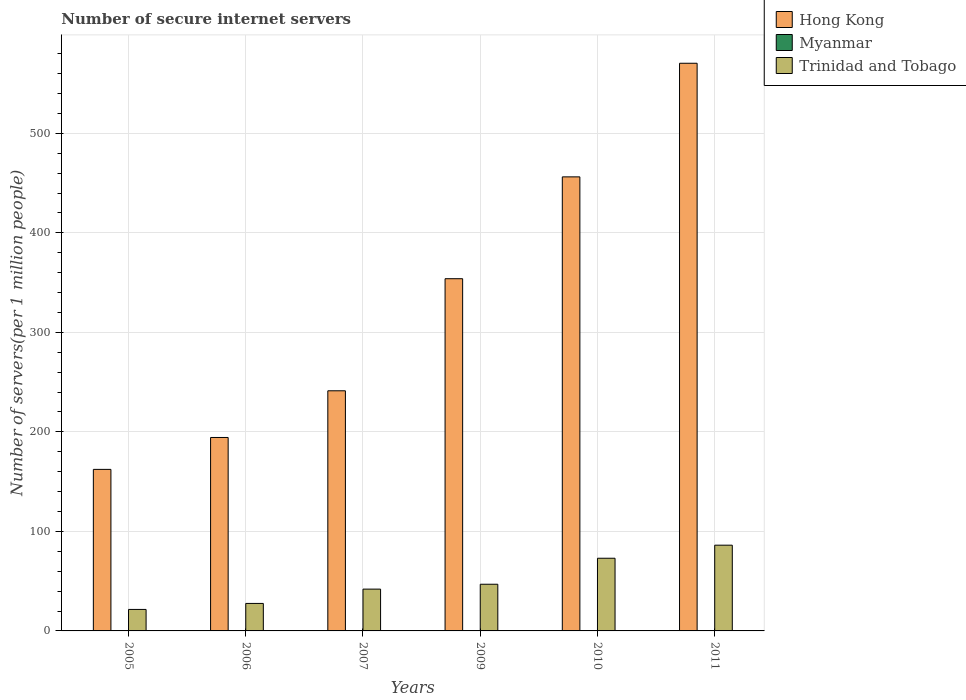Are the number of bars per tick equal to the number of legend labels?
Keep it short and to the point. Yes. What is the label of the 1st group of bars from the left?
Ensure brevity in your answer.  2005. What is the number of secure internet servers in Trinidad and Tobago in 2010?
Ensure brevity in your answer.  73.04. Across all years, what is the maximum number of secure internet servers in Trinidad and Tobago?
Keep it short and to the point. 86.16. Across all years, what is the minimum number of secure internet servers in Myanmar?
Give a very brief answer. 0.02. In which year was the number of secure internet servers in Hong Kong minimum?
Make the answer very short. 2005. What is the total number of secure internet servers in Hong Kong in the graph?
Ensure brevity in your answer.  1978.72. What is the difference between the number of secure internet servers in Hong Kong in 2006 and that in 2009?
Make the answer very short. -159.55. What is the difference between the number of secure internet servers in Trinidad and Tobago in 2011 and the number of secure internet servers in Myanmar in 2010?
Provide a succinct answer. 86.1. What is the average number of secure internet servers in Myanmar per year?
Your response must be concise. 0.04. In the year 2010, what is the difference between the number of secure internet servers in Trinidad and Tobago and number of secure internet servers in Myanmar?
Keep it short and to the point. 72.98. In how many years, is the number of secure internet servers in Myanmar greater than 280?
Ensure brevity in your answer.  0. What is the ratio of the number of secure internet servers in Hong Kong in 2006 to that in 2007?
Make the answer very short. 0.81. What is the difference between the highest and the second highest number of secure internet servers in Hong Kong?
Offer a very short reply. 114.17. What is the difference between the highest and the lowest number of secure internet servers in Trinidad and Tobago?
Offer a very short reply. 64.57. What does the 1st bar from the left in 2006 represents?
Ensure brevity in your answer.  Hong Kong. What does the 2nd bar from the right in 2010 represents?
Keep it short and to the point. Myanmar. Is it the case that in every year, the sum of the number of secure internet servers in Hong Kong and number of secure internet servers in Myanmar is greater than the number of secure internet servers in Trinidad and Tobago?
Make the answer very short. Yes. How many bars are there?
Provide a succinct answer. 18. How many years are there in the graph?
Provide a succinct answer. 6. What is the difference between two consecutive major ticks on the Y-axis?
Give a very brief answer. 100. Are the values on the major ticks of Y-axis written in scientific E-notation?
Give a very brief answer. No. Does the graph contain any zero values?
Offer a terse response. No. What is the title of the graph?
Your answer should be compact. Number of secure internet servers. Does "Haiti" appear as one of the legend labels in the graph?
Your response must be concise. No. What is the label or title of the Y-axis?
Make the answer very short. Number of servers(per 1 million people). What is the Number of servers(per 1 million people) of Hong Kong in 2005?
Offer a terse response. 162.33. What is the Number of servers(per 1 million people) in Myanmar in 2005?
Make the answer very short. 0.02. What is the Number of servers(per 1 million people) of Trinidad and Tobago in 2005?
Ensure brevity in your answer.  21.59. What is the Number of servers(per 1 million people) in Hong Kong in 2006?
Offer a terse response. 194.4. What is the Number of servers(per 1 million people) in Myanmar in 2006?
Your response must be concise. 0.04. What is the Number of servers(per 1 million people) of Trinidad and Tobago in 2006?
Provide a succinct answer. 27.63. What is the Number of servers(per 1 million people) in Hong Kong in 2007?
Provide a short and direct response. 241.31. What is the Number of servers(per 1 million people) of Myanmar in 2007?
Make the answer very short. 0.02. What is the Number of servers(per 1 million people) in Trinidad and Tobago in 2007?
Your answer should be very brief. 42.01. What is the Number of servers(per 1 million people) of Hong Kong in 2009?
Your response must be concise. 353.95. What is the Number of servers(per 1 million people) in Myanmar in 2009?
Provide a succinct answer. 0.02. What is the Number of servers(per 1 million people) in Trinidad and Tobago in 2009?
Offer a terse response. 46.91. What is the Number of servers(per 1 million people) in Hong Kong in 2010?
Make the answer very short. 456.28. What is the Number of servers(per 1 million people) of Myanmar in 2010?
Give a very brief answer. 0.06. What is the Number of servers(per 1 million people) in Trinidad and Tobago in 2010?
Your response must be concise. 73.04. What is the Number of servers(per 1 million people) of Hong Kong in 2011?
Make the answer very short. 570.45. What is the Number of servers(per 1 million people) of Myanmar in 2011?
Offer a terse response. 0.08. What is the Number of servers(per 1 million people) of Trinidad and Tobago in 2011?
Your answer should be compact. 86.16. Across all years, what is the maximum Number of servers(per 1 million people) of Hong Kong?
Keep it short and to the point. 570.45. Across all years, what is the maximum Number of servers(per 1 million people) of Myanmar?
Provide a short and direct response. 0.08. Across all years, what is the maximum Number of servers(per 1 million people) of Trinidad and Tobago?
Provide a short and direct response. 86.16. Across all years, what is the minimum Number of servers(per 1 million people) in Hong Kong?
Make the answer very short. 162.33. Across all years, what is the minimum Number of servers(per 1 million people) of Myanmar?
Provide a short and direct response. 0.02. Across all years, what is the minimum Number of servers(per 1 million people) in Trinidad and Tobago?
Offer a terse response. 21.59. What is the total Number of servers(per 1 million people) in Hong Kong in the graph?
Make the answer very short. 1978.72. What is the total Number of servers(per 1 million people) of Myanmar in the graph?
Your answer should be compact. 0.23. What is the total Number of servers(per 1 million people) of Trinidad and Tobago in the graph?
Your answer should be very brief. 297.33. What is the difference between the Number of servers(per 1 million people) of Hong Kong in 2005 and that in 2006?
Keep it short and to the point. -32.07. What is the difference between the Number of servers(per 1 million people) of Myanmar in 2005 and that in 2006?
Give a very brief answer. -0.02. What is the difference between the Number of servers(per 1 million people) in Trinidad and Tobago in 2005 and that in 2006?
Your response must be concise. -6.04. What is the difference between the Number of servers(per 1 million people) of Hong Kong in 2005 and that in 2007?
Provide a short and direct response. -78.98. What is the difference between the Number of servers(per 1 million people) in Myanmar in 2005 and that in 2007?
Your response must be concise. 0. What is the difference between the Number of servers(per 1 million people) in Trinidad and Tobago in 2005 and that in 2007?
Offer a terse response. -20.42. What is the difference between the Number of servers(per 1 million people) in Hong Kong in 2005 and that in 2009?
Your response must be concise. -191.61. What is the difference between the Number of servers(per 1 million people) of Myanmar in 2005 and that in 2009?
Offer a very short reply. 0. What is the difference between the Number of servers(per 1 million people) in Trinidad and Tobago in 2005 and that in 2009?
Your answer should be compact. -25.32. What is the difference between the Number of servers(per 1 million people) in Hong Kong in 2005 and that in 2010?
Ensure brevity in your answer.  -293.95. What is the difference between the Number of servers(per 1 million people) in Myanmar in 2005 and that in 2010?
Your answer should be very brief. -0.04. What is the difference between the Number of servers(per 1 million people) of Trinidad and Tobago in 2005 and that in 2010?
Make the answer very short. -51.45. What is the difference between the Number of servers(per 1 million people) in Hong Kong in 2005 and that in 2011?
Your response must be concise. -408.12. What is the difference between the Number of servers(per 1 million people) of Myanmar in 2005 and that in 2011?
Make the answer very short. -0.06. What is the difference between the Number of servers(per 1 million people) in Trinidad and Tobago in 2005 and that in 2011?
Provide a succinct answer. -64.57. What is the difference between the Number of servers(per 1 million people) of Hong Kong in 2006 and that in 2007?
Ensure brevity in your answer.  -46.92. What is the difference between the Number of servers(per 1 million people) of Myanmar in 2006 and that in 2007?
Make the answer very short. 0.02. What is the difference between the Number of servers(per 1 million people) of Trinidad and Tobago in 2006 and that in 2007?
Ensure brevity in your answer.  -14.38. What is the difference between the Number of servers(per 1 million people) of Hong Kong in 2006 and that in 2009?
Keep it short and to the point. -159.55. What is the difference between the Number of servers(per 1 million people) of Myanmar in 2006 and that in 2009?
Keep it short and to the point. 0.02. What is the difference between the Number of servers(per 1 million people) in Trinidad and Tobago in 2006 and that in 2009?
Give a very brief answer. -19.29. What is the difference between the Number of servers(per 1 million people) of Hong Kong in 2006 and that in 2010?
Provide a succinct answer. -261.88. What is the difference between the Number of servers(per 1 million people) of Myanmar in 2006 and that in 2010?
Ensure brevity in your answer.  -0.02. What is the difference between the Number of servers(per 1 million people) of Trinidad and Tobago in 2006 and that in 2010?
Offer a terse response. -45.41. What is the difference between the Number of servers(per 1 million people) in Hong Kong in 2006 and that in 2011?
Your answer should be compact. -376.05. What is the difference between the Number of servers(per 1 million people) of Myanmar in 2006 and that in 2011?
Offer a very short reply. -0.04. What is the difference between the Number of servers(per 1 million people) in Trinidad and Tobago in 2006 and that in 2011?
Ensure brevity in your answer.  -58.53. What is the difference between the Number of servers(per 1 million people) in Hong Kong in 2007 and that in 2009?
Your response must be concise. -112.63. What is the difference between the Number of servers(per 1 million people) in Trinidad and Tobago in 2007 and that in 2009?
Give a very brief answer. -4.9. What is the difference between the Number of servers(per 1 million people) of Hong Kong in 2007 and that in 2010?
Offer a terse response. -214.97. What is the difference between the Number of servers(per 1 million people) of Myanmar in 2007 and that in 2010?
Provide a succinct answer. -0.04. What is the difference between the Number of servers(per 1 million people) of Trinidad and Tobago in 2007 and that in 2010?
Your response must be concise. -31.03. What is the difference between the Number of servers(per 1 million people) in Hong Kong in 2007 and that in 2011?
Give a very brief answer. -329.14. What is the difference between the Number of servers(per 1 million people) of Myanmar in 2007 and that in 2011?
Offer a very short reply. -0.06. What is the difference between the Number of servers(per 1 million people) of Trinidad and Tobago in 2007 and that in 2011?
Provide a succinct answer. -44.15. What is the difference between the Number of servers(per 1 million people) of Hong Kong in 2009 and that in 2010?
Keep it short and to the point. -102.33. What is the difference between the Number of servers(per 1 million people) in Myanmar in 2009 and that in 2010?
Ensure brevity in your answer.  -0.04. What is the difference between the Number of servers(per 1 million people) in Trinidad and Tobago in 2009 and that in 2010?
Your answer should be very brief. -26.12. What is the difference between the Number of servers(per 1 million people) in Hong Kong in 2009 and that in 2011?
Your answer should be compact. -216.5. What is the difference between the Number of servers(per 1 million people) of Myanmar in 2009 and that in 2011?
Provide a succinct answer. -0.06. What is the difference between the Number of servers(per 1 million people) in Trinidad and Tobago in 2009 and that in 2011?
Make the answer very short. -39.24. What is the difference between the Number of servers(per 1 million people) in Hong Kong in 2010 and that in 2011?
Your answer should be very brief. -114.17. What is the difference between the Number of servers(per 1 million people) in Myanmar in 2010 and that in 2011?
Ensure brevity in your answer.  -0.02. What is the difference between the Number of servers(per 1 million people) in Trinidad and Tobago in 2010 and that in 2011?
Provide a succinct answer. -13.12. What is the difference between the Number of servers(per 1 million people) of Hong Kong in 2005 and the Number of servers(per 1 million people) of Myanmar in 2006?
Keep it short and to the point. 162.29. What is the difference between the Number of servers(per 1 million people) in Hong Kong in 2005 and the Number of servers(per 1 million people) in Trinidad and Tobago in 2006?
Offer a terse response. 134.71. What is the difference between the Number of servers(per 1 million people) in Myanmar in 2005 and the Number of servers(per 1 million people) in Trinidad and Tobago in 2006?
Keep it short and to the point. -27.61. What is the difference between the Number of servers(per 1 million people) of Hong Kong in 2005 and the Number of servers(per 1 million people) of Myanmar in 2007?
Keep it short and to the point. 162.31. What is the difference between the Number of servers(per 1 million people) of Hong Kong in 2005 and the Number of servers(per 1 million people) of Trinidad and Tobago in 2007?
Provide a succinct answer. 120.32. What is the difference between the Number of servers(per 1 million people) in Myanmar in 2005 and the Number of servers(per 1 million people) in Trinidad and Tobago in 2007?
Offer a very short reply. -41.99. What is the difference between the Number of servers(per 1 million people) in Hong Kong in 2005 and the Number of servers(per 1 million people) in Myanmar in 2009?
Keep it short and to the point. 162.31. What is the difference between the Number of servers(per 1 million people) in Hong Kong in 2005 and the Number of servers(per 1 million people) in Trinidad and Tobago in 2009?
Your answer should be very brief. 115.42. What is the difference between the Number of servers(per 1 million people) of Myanmar in 2005 and the Number of servers(per 1 million people) of Trinidad and Tobago in 2009?
Offer a terse response. -46.89. What is the difference between the Number of servers(per 1 million people) of Hong Kong in 2005 and the Number of servers(per 1 million people) of Myanmar in 2010?
Give a very brief answer. 162.27. What is the difference between the Number of servers(per 1 million people) in Hong Kong in 2005 and the Number of servers(per 1 million people) in Trinidad and Tobago in 2010?
Give a very brief answer. 89.3. What is the difference between the Number of servers(per 1 million people) of Myanmar in 2005 and the Number of servers(per 1 million people) of Trinidad and Tobago in 2010?
Provide a short and direct response. -73.02. What is the difference between the Number of servers(per 1 million people) of Hong Kong in 2005 and the Number of servers(per 1 million people) of Myanmar in 2011?
Your answer should be compact. 162.26. What is the difference between the Number of servers(per 1 million people) of Hong Kong in 2005 and the Number of servers(per 1 million people) of Trinidad and Tobago in 2011?
Provide a succinct answer. 76.18. What is the difference between the Number of servers(per 1 million people) of Myanmar in 2005 and the Number of servers(per 1 million people) of Trinidad and Tobago in 2011?
Provide a short and direct response. -86.14. What is the difference between the Number of servers(per 1 million people) in Hong Kong in 2006 and the Number of servers(per 1 million people) in Myanmar in 2007?
Keep it short and to the point. 194.38. What is the difference between the Number of servers(per 1 million people) in Hong Kong in 2006 and the Number of servers(per 1 million people) in Trinidad and Tobago in 2007?
Give a very brief answer. 152.39. What is the difference between the Number of servers(per 1 million people) in Myanmar in 2006 and the Number of servers(per 1 million people) in Trinidad and Tobago in 2007?
Your response must be concise. -41.97. What is the difference between the Number of servers(per 1 million people) in Hong Kong in 2006 and the Number of servers(per 1 million people) in Myanmar in 2009?
Ensure brevity in your answer.  194.38. What is the difference between the Number of servers(per 1 million people) of Hong Kong in 2006 and the Number of servers(per 1 million people) of Trinidad and Tobago in 2009?
Your response must be concise. 147.49. What is the difference between the Number of servers(per 1 million people) of Myanmar in 2006 and the Number of servers(per 1 million people) of Trinidad and Tobago in 2009?
Ensure brevity in your answer.  -46.87. What is the difference between the Number of servers(per 1 million people) in Hong Kong in 2006 and the Number of servers(per 1 million people) in Myanmar in 2010?
Keep it short and to the point. 194.34. What is the difference between the Number of servers(per 1 million people) of Hong Kong in 2006 and the Number of servers(per 1 million people) of Trinidad and Tobago in 2010?
Ensure brevity in your answer.  121.36. What is the difference between the Number of servers(per 1 million people) in Myanmar in 2006 and the Number of servers(per 1 million people) in Trinidad and Tobago in 2010?
Your answer should be very brief. -73. What is the difference between the Number of servers(per 1 million people) of Hong Kong in 2006 and the Number of servers(per 1 million people) of Myanmar in 2011?
Give a very brief answer. 194.32. What is the difference between the Number of servers(per 1 million people) of Hong Kong in 2006 and the Number of servers(per 1 million people) of Trinidad and Tobago in 2011?
Ensure brevity in your answer.  108.24. What is the difference between the Number of servers(per 1 million people) in Myanmar in 2006 and the Number of servers(per 1 million people) in Trinidad and Tobago in 2011?
Give a very brief answer. -86.12. What is the difference between the Number of servers(per 1 million people) of Hong Kong in 2007 and the Number of servers(per 1 million people) of Myanmar in 2009?
Provide a short and direct response. 241.29. What is the difference between the Number of servers(per 1 million people) in Hong Kong in 2007 and the Number of servers(per 1 million people) in Trinidad and Tobago in 2009?
Make the answer very short. 194.4. What is the difference between the Number of servers(per 1 million people) in Myanmar in 2007 and the Number of servers(per 1 million people) in Trinidad and Tobago in 2009?
Offer a very short reply. -46.89. What is the difference between the Number of servers(per 1 million people) in Hong Kong in 2007 and the Number of servers(per 1 million people) in Myanmar in 2010?
Your response must be concise. 241.26. What is the difference between the Number of servers(per 1 million people) in Hong Kong in 2007 and the Number of servers(per 1 million people) in Trinidad and Tobago in 2010?
Your response must be concise. 168.28. What is the difference between the Number of servers(per 1 million people) of Myanmar in 2007 and the Number of servers(per 1 million people) of Trinidad and Tobago in 2010?
Provide a succinct answer. -73.02. What is the difference between the Number of servers(per 1 million people) in Hong Kong in 2007 and the Number of servers(per 1 million people) in Myanmar in 2011?
Provide a short and direct response. 241.24. What is the difference between the Number of servers(per 1 million people) of Hong Kong in 2007 and the Number of servers(per 1 million people) of Trinidad and Tobago in 2011?
Provide a succinct answer. 155.16. What is the difference between the Number of servers(per 1 million people) of Myanmar in 2007 and the Number of servers(per 1 million people) of Trinidad and Tobago in 2011?
Offer a terse response. -86.14. What is the difference between the Number of servers(per 1 million people) of Hong Kong in 2009 and the Number of servers(per 1 million people) of Myanmar in 2010?
Give a very brief answer. 353.89. What is the difference between the Number of servers(per 1 million people) in Hong Kong in 2009 and the Number of servers(per 1 million people) in Trinidad and Tobago in 2010?
Your answer should be compact. 280.91. What is the difference between the Number of servers(per 1 million people) of Myanmar in 2009 and the Number of servers(per 1 million people) of Trinidad and Tobago in 2010?
Offer a terse response. -73.02. What is the difference between the Number of servers(per 1 million people) of Hong Kong in 2009 and the Number of servers(per 1 million people) of Myanmar in 2011?
Make the answer very short. 353.87. What is the difference between the Number of servers(per 1 million people) of Hong Kong in 2009 and the Number of servers(per 1 million people) of Trinidad and Tobago in 2011?
Provide a succinct answer. 267.79. What is the difference between the Number of servers(per 1 million people) of Myanmar in 2009 and the Number of servers(per 1 million people) of Trinidad and Tobago in 2011?
Ensure brevity in your answer.  -86.14. What is the difference between the Number of servers(per 1 million people) of Hong Kong in 2010 and the Number of servers(per 1 million people) of Myanmar in 2011?
Provide a succinct answer. 456.2. What is the difference between the Number of servers(per 1 million people) of Hong Kong in 2010 and the Number of servers(per 1 million people) of Trinidad and Tobago in 2011?
Ensure brevity in your answer.  370.12. What is the difference between the Number of servers(per 1 million people) of Myanmar in 2010 and the Number of servers(per 1 million people) of Trinidad and Tobago in 2011?
Your answer should be compact. -86.1. What is the average Number of servers(per 1 million people) of Hong Kong per year?
Ensure brevity in your answer.  329.79. What is the average Number of servers(per 1 million people) in Myanmar per year?
Your answer should be very brief. 0.04. What is the average Number of servers(per 1 million people) in Trinidad and Tobago per year?
Keep it short and to the point. 49.55. In the year 2005, what is the difference between the Number of servers(per 1 million people) of Hong Kong and Number of servers(per 1 million people) of Myanmar?
Offer a terse response. 162.31. In the year 2005, what is the difference between the Number of servers(per 1 million people) in Hong Kong and Number of servers(per 1 million people) in Trinidad and Tobago?
Provide a succinct answer. 140.74. In the year 2005, what is the difference between the Number of servers(per 1 million people) in Myanmar and Number of servers(per 1 million people) in Trinidad and Tobago?
Offer a very short reply. -21.57. In the year 2006, what is the difference between the Number of servers(per 1 million people) in Hong Kong and Number of servers(per 1 million people) in Myanmar?
Offer a very short reply. 194.36. In the year 2006, what is the difference between the Number of servers(per 1 million people) of Hong Kong and Number of servers(per 1 million people) of Trinidad and Tobago?
Offer a very short reply. 166.77. In the year 2006, what is the difference between the Number of servers(per 1 million people) in Myanmar and Number of servers(per 1 million people) in Trinidad and Tobago?
Give a very brief answer. -27.59. In the year 2007, what is the difference between the Number of servers(per 1 million people) in Hong Kong and Number of servers(per 1 million people) in Myanmar?
Your answer should be very brief. 241.29. In the year 2007, what is the difference between the Number of servers(per 1 million people) in Hong Kong and Number of servers(per 1 million people) in Trinidad and Tobago?
Offer a terse response. 199.31. In the year 2007, what is the difference between the Number of servers(per 1 million people) of Myanmar and Number of servers(per 1 million people) of Trinidad and Tobago?
Provide a short and direct response. -41.99. In the year 2009, what is the difference between the Number of servers(per 1 million people) in Hong Kong and Number of servers(per 1 million people) in Myanmar?
Keep it short and to the point. 353.93. In the year 2009, what is the difference between the Number of servers(per 1 million people) in Hong Kong and Number of servers(per 1 million people) in Trinidad and Tobago?
Your answer should be compact. 307.03. In the year 2009, what is the difference between the Number of servers(per 1 million people) in Myanmar and Number of servers(per 1 million people) in Trinidad and Tobago?
Your answer should be compact. -46.89. In the year 2010, what is the difference between the Number of servers(per 1 million people) of Hong Kong and Number of servers(per 1 million people) of Myanmar?
Ensure brevity in your answer.  456.22. In the year 2010, what is the difference between the Number of servers(per 1 million people) of Hong Kong and Number of servers(per 1 million people) of Trinidad and Tobago?
Your response must be concise. 383.24. In the year 2010, what is the difference between the Number of servers(per 1 million people) of Myanmar and Number of servers(per 1 million people) of Trinidad and Tobago?
Your answer should be very brief. -72.98. In the year 2011, what is the difference between the Number of servers(per 1 million people) in Hong Kong and Number of servers(per 1 million people) in Myanmar?
Make the answer very short. 570.37. In the year 2011, what is the difference between the Number of servers(per 1 million people) in Hong Kong and Number of servers(per 1 million people) in Trinidad and Tobago?
Your answer should be compact. 484.29. In the year 2011, what is the difference between the Number of servers(per 1 million people) of Myanmar and Number of servers(per 1 million people) of Trinidad and Tobago?
Offer a very short reply. -86.08. What is the ratio of the Number of servers(per 1 million people) of Hong Kong in 2005 to that in 2006?
Your answer should be compact. 0.84. What is the ratio of the Number of servers(per 1 million people) of Myanmar in 2005 to that in 2006?
Offer a terse response. 0.5. What is the ratio of the Number of servers(per 1 million people) in Trinidad and Tobago in 2005 to that in 2006?
Your answer should be compact. 0.78. What is the ratio of the Number of servers(per 1 million people) of Hong Kong in 2005 to that in 2007?
Your answer should be very brief. 0.67. What is the ratio of the Number of servers(per 1 million people) of Myanmar in 2005 to that in 2007?
Your response must be concise. 1.01. What is the ratio of the Number of servers(per 1 million people) in Trinidad and Tobago in 2005 to that in 2007?
Keep it short and to the point. 0.51. What is the ratio of the Number of servers(per 1 million people) of Hong Kong in 2005 to that in 2009?
Your answer should be very brief. 0.46. What is the ratio of the Number of servers(per 1 million people) in Myanmar in 2005 to that in 2009?
Your response must be concise. 1.03. What is the ratio of the Number of servers(per 1 million people) in Trinidad and Tobago in 2005 to that in 2009?
Keep it short and to the point. 0.46. What is the ratio of the Number of servers(per 1 million people) in Hong Kong in 2005 to that in 2010?
Offer a very short reply. 0.36. What is the ratio of the Number of servers(per 1 million people) of Myanmar in 2005 to that in 2010?
Your answer should be compact. 0.34. What is the ratio of the Number of servers(per 1 million people) of Trinidad and Tobago in 2005 to that in 2010?
Provide a succinct answer. 0.3. What is the ratio of the Number of servers(per 1 million people) of Hong Kong in 2005 to that in 2011?
Your answer should be very brief. 0.28. What is the ratio of the Number of servers(per 1 million people) of Myanmar in 2005 to that in 2011?
Provide a succinct answer. 0.26. What is the ratio of the Number of servers(per 1 million people) in Trinidad and Tobago in 2005 to that in 2011?
Your answer should be very brief. 0.25. What is the ratio of the Number of servers(per 1 million people) of Hong Kong in 2006 to that in 2007?
Offer a terse response. 0.81. What is the ratio of the Number of servers(per 1 million people) of Myanmar in 2006 to that in 2007?
Ensure brevity in your answer.  2.01. What is the ratio of the Number of servers(per 1 million people) of Trinidad and Tobago in 2006 to that in 2007?
Give a very brief answer. 0.66. What is the ratio of the Number of servers(per 1 million people) of Hong Kong in 2006 to that in 2009?
Your answer should be very brief. 0.55. What is the ratio of the Number of servers(per 1 million people) in Myanmar in 2006 to that in 2009?
Ensure brevity in your answer.  2.04. What is the ratio of the Number of servers(per 1 million people) in Trinidad and Tobago in 2006 to that in 2009?
Offer a very short reply. 0.59. What is the ratio of the Number of servers(per 1 million people) in Hong Kong in 2006 to that in 2010?
Offer a terse response. 0.43. What is the ratio of the Number of servers(per 1 million people) of Myanmar in 2006 to that in 2010?
Provide a short and direct response. 0.68. What is the ratio of the Number of servers(per 1 million people) in Trinidad and Tobago in 2006 to that in 2010?
Keep it short and to the point. 0.38. What is the ratio of the Number of servers(per 1 million people) of Hong Kong in 2006 to that in 2011?
Make the answer very short. 0.34. What is the ratio of the Number of servers(per 1 million people) of Myanmar in 2006 to that in 2011?
Make the answer very short. 0.52. What is the ratio of the Number of servers(per 1 million people) in Trinidad and Tobago in 2006 to that in 2011?
Keep it short and to the point. 0.32. What is the ratio of the Number of servers(per 1 million people) in Hong Kong in 2007 to that in 2009?
Your answer should be very brief. 0.68. What is the ratio of the Number of servers(per 1 million people) of Myanmar in 2007 to that in 2009?
Keep it short and to the point. 1.01. What is the ratio of the Number of servers(per 1 million people) of Trinidad and Tobago in 2007 to that in 2009?
Give a very brief answer. 0.9. What is the ratio of the Number of servers(per 1 million people) of Hong Kong in 2007 to that in 2010?
Make the answer very short. 0.53. What is the ratio of the Number of servers(per 1 million people) in Myanmar in 2007 to that in 2010?
Your answer should be very brief. 0.34. What is the ratio of the Number of servers(per 1 million people) in Trinidad and Tobago in 2007 to that in 2010?
Provide a succinct answer. 0.58. What is the ratio of the Number of servers(per 1 million people) of Hong Kong in 2007 to that in 2011?
Keep it short and to the point. 0.42. What is the ratio of the Number of servers(per 1 million people) in Myanmar in 2007 to that in 2011?
Your response must be concise. 0.26. What is the ratio of the Number of servers(per 1 million people) in Trinidad and Tobago in 2007 to that in 2011?
Provide a succinct answer. 0.49. What is the ratio of the Number of servers(per 1 million people) in Hong Kong in 2009 to that in 2010?
Your answer should be compact. 0.78. What is the ratio of the Number of servers(per 1 million people) in Myanmar in 2009 to that in 2010?
Give a very brief answer. 0.34. What is the ratio of the Number of servers(per 1 million people) in Trinidad and Tobago in 2009 to that in 2010?
Your answer should be very brief. 0.64. What is the ratio of the Number of servers(per 1 million people) of Hong Kong in 2009 to that in 2011?
Offer a terse response. 0.62. What is the ratio of the Number of servers(per 1 million people) of Myanmar in 2009 to that in 2011?
Give a very brief answer. 0.25. What is the ratio of the Number of servers(per 1 million people) of Trinidad and Tobago in 2009 to that in 2011?
Offer a very short reply. 0.54. What is the ratio of the Number of servers(per 1 million people) in Hong Kong in 2010 to that in 2011?
Ensure brevity in your answer.  0.8. What is the ratio of the Number of servers(per 1 million people) of Myanmar in 2010 to that in 2011?
Make the answer very short. 0.76. What is the ratio of the Number of servers(per 1 million people) of Trinidad and Tobago in 2010 to that in 2011?
Make the answer very short. 0.85. What is the difference between the highest and the second highest Number of servers(per 1 million people) in Hong Kong?
Offer a very short reply. 114.17. What is the difference between the highest and the second highest Number of servers(per 1 million people) in Myanmar?
Ensure brevity in your answer.  0.02. What is the difference between the highest and the second highest Number of servers(per 1 million people) of Trinidad and Tobago?
Offer a very short reply. 13.12. What is the difference between the highest and the lowest Number of servers(per 1 million people) of Hong Kong?
Ensure brevity in your answer.  408.12. What is the difference between the highest and the lowest Number of servers(per 1 million people) in Myanmar?
Offer a terse response. 0.06. What is the difference between the highest and the lowest Number of servers(per 1 million people) in Trinidad and Tobago?
Offer a very short reply. 64.57. 